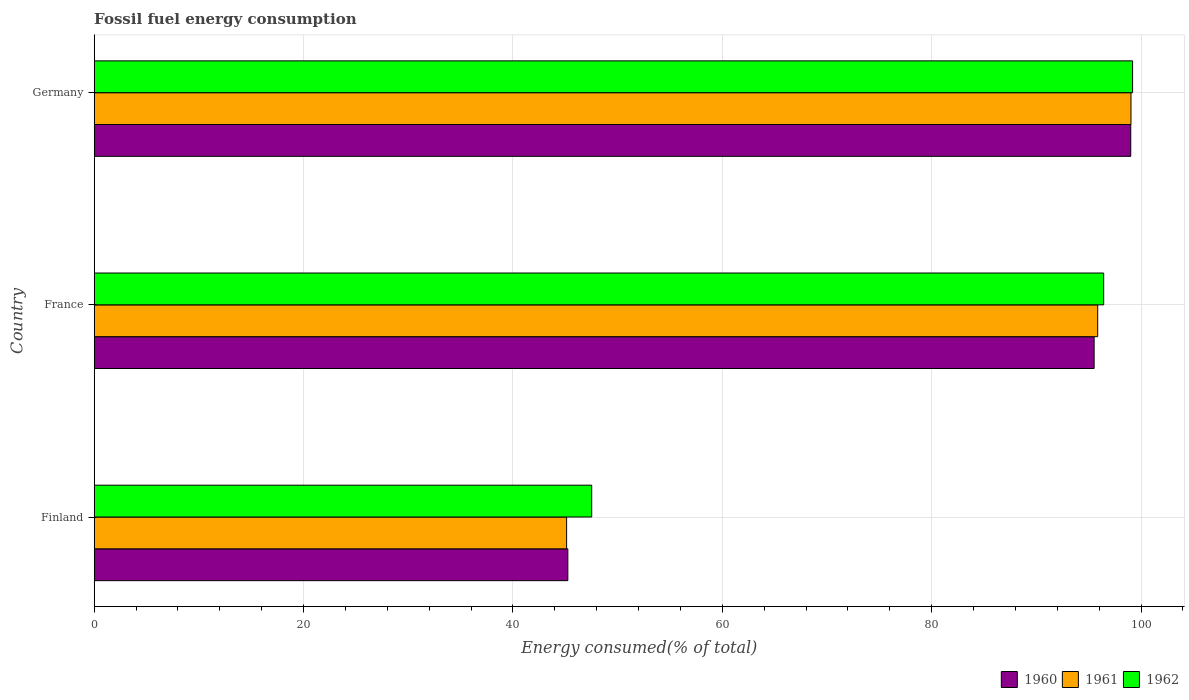How many groups of bars are there?
Ensure brevity in your answer.  3. Are the number of bars on each tick of the Y-axis equal?
Provide a succinct answer. Yes. In how many cases, is the number of bars for a given country not equal to the number of legend labels?
Ensure brevity in your answer.  0. What is the percentage of energy consumed in 1961 in Germany?
Keep it short and to the point. 99.04. Across all countries, what is the maximum percentage of energy consumed in 1960?
Give a very brief answer. 99.02. Across all countries, what is the minimum percentage of energy consumed in 1961?
Provide a short and direct response. 45.13. In which country was the percentage of energy consumed in 1962 maximum?
Your response must be concise. Germany. In which country was the percentage of energy consumed in 1962 minimum?
Offer a terse response. Finland. What is the total percentage of energy consumed in 1960 in the graph?
Give a very brief answer. 239.79. What is the difference between the percentage of energy consumed in 1961 in Finland and that in Germany?
Offer a terse response. -53.91. What is the difference between the percentage of energy consumed in 1960 in Germany and the percentage of energy consumed in 1961 in Finland?
Ensure brevity in your answer.  53.89. What is the average percentage of energy consumed in 1961 per country?
Give a very brief answer. 80.01. What is the difference between the percentage of energy consumed in 1960 and percentage of energy consumed in 1961 in France?
Your response must be concise. -0.34. What is the ratio of the percentage of energy consumed in 1960 in France to that in Germany?
Keep it short and to the point. 0.96. Is the percentage of energy consumed in 1960 in France less than that in Germany?
Make the answer very short. Yes. What is the difference between the highest and the second highest percentage of energy consumed in 1962?
Your answer should be compact. 2.76. What is the difference between the highest and the lowest percentage of energy consumed in 1960?
Offer a very short reply. 53.77. Is the sum of the percentage of energy consumed in 1960 in Finland and Germany greater than the maximum percentage of energy consumed in 1961 across all countries?
Your answer should be very brief. Yes. What does the 3rd bar from the top in Finland represents?
Ensure brevity in your answer.  1960. Are the values on the major ticks of X-axis written in scientific E-notation?
Your answer should be very brief. No. Does the graph contain any zero values?
Give a very brief answer. No. Does the graph contain grids?
Provide a succinct answer. Yes. How many legend labels are there?
Your answer should be very brief. 3. What is the title of the graph?
Your response must be concise. Fossil fuel energy consumption. What is the label or title of the X-axis?
Ensure brevity in your answer.  Energy consumed(% of total). What is the label or title of the Y-axis?
Offer a very short reply. Country. What is the Energy consumed(% of total) of 1960 in Finland?
Your answer should be compact. 45.25. What is the Energy consumed(% of total) in 1961 in Finland?
Your answer should be very brief. 45.13. What is the Energy consumed(% of total) in 1962 in Finland?
Provide a succinct answer. 47.52. What is the Energy consumed(% of total) of 1960 in France?
Provide a succinct answer. 95.52. What is the Energy consumed(% of total) in 1961 in France?
Make the answer very short. 95.86. What is the Energy consumed(% of total) of 1962 in France?
Your response must be concise. 96.43. What is the Energy consumed(% of total) of 1960 in Germany?
Offer a terse response. 99.02. What is the Energy consumed(% of total) of 1961 in Germany?
Ensure brevity in your answer.  99.04. What is the Energy consumed(% of total) of 1962 in Germany?
Offer a terse response. 99.19. Across all countries, what is the maximum Energy consumed(% of total) in 1960?
Your response must be concise. 99.02. Across all countries, what is the maximum Energy consumed(% of total) of 1961?
Give a very brief answer. 99.04. Across all countries, what is the maximum Energy consumed(% of total) of 1962?
Your answer should be compact. 99.19. Across all countries, what is the minimum Energy consumed(% of total) of 1960?
Provide a short and direct response. 45.25. Across all countries, what is the minimum Energy consumed(% of total) of 1961?
Ensure brevity in your answer.  45.13. Across all countries, what is the minimum Energy consumed(% of total) of 1962?
Offer a very short reply. 47.52. What is the total Energy consumed(% of total) in 1960 in the graph?
Your answer should be compact. 239.79. What is the total Energy consumed(% of total) in 1961 in the graph?
Make the answer very short. 240.03. What is the total Energy consumed(% of total) of 1962 in the graph?
Ensure brevity in your answer.  243.15. What is the difference between the Energy consumed(% of total) in 1960 in Finland and that in France?
Offer a terse response. -50.27. What is the difference between the Energy consumed(% of total) of 1961 in Finland and that in France?
Provide a short and direct response. -50.73. What is the difference between the Energy consumed(% of total) of 1962 in Finland and that in France?
Your response must be concise. -48.91. What is the difference between the Energy consumed(% of total) in 1960 in Finland and that in Germany?
Make the answer very short. -53.77. What is the difference between the Energy consumed(% of total) in 1961 in Finland and that in Germany?
Offer a very short reply. -53.91. What is the difference between the Energy consumed(% of total) in 1962 in Finland and that in Germany?
Provide a short and direct response. -51.67. What is the difference between the Energy consumed(% of total) of 1960 in France and that in Germany?
Make the answer very short. -3.5. What is the difference between the Energy consumed(% of total) in 1961 in France and that in Germany?
Offer a very short reply. -3.18. What is the difference between the Energy consumed(% of total) in 1962 in France and that in Germany?
Offer a very short reply. -2.76. What is the difference between the Energy consumed(% of total) in 1960 in Finland and the Energy consumed(% of total) in 1961 in France?
Give a very brief answer. -50.62. What is the difference between the Energy consumed(% of total) of 1960 in Finland and the Energy consumed(% of total) of 1962 in France?
Keep it short and to the point. -51.19. What is the difference between the Energy consumed(% of total) in 1961 in Finland and the Energy consumed(% of total) in 1962 in France?
Provide a succinct answer. -51.3. What is the difference between the Energy consumed(% of total) in 1960 in Finland and the Energy consumed(% of total) in 1961 in Germany?
Give a very brief answer. -53.8. What is the difference between the Energy consumed(% of total) of 1960 in Finland and the Energy consumed(% of total) of 1962 in Germany?
Ensure brevity in your answer.  -53.95. What is the difference between the Energy consumed(% of total) in 1961 in Finland and the Energy consumed(% of total) in 1962 in Germany?
Give a very brief answer. -54.06. What is the difference between the Energy consumed(% of total) in 1960 in France and the Energy consumed(% of total) in 1961 in Germany?
Provide a succinct answer. -3.52. What is the difference between the Energy consumed(% of total) of 1960 in France and the Energy consumed(% of total) of 1962 in Germany?
Ensure brevity in your answer.  -3.67. What is the difference between the Energy consumed(% of total) of 1961 in France and the Energy consumed(% of total) of 1962 in Germany?
Provide a short and direct response. -3.33. What is the average Energy consumed(% of total) of 1960 per country?
Keep it short and to the point. 79.93. What is the average Energy consumed(% of total) in 1961 per country?
Offer a terse response. 80.01. What is the average Energy consumed(% of total) of 1962 per country?
Your answer should be compact. 81.05. What is the difference between the Energy consumed(% of total) of 1960 and Energy consumed(% of total) of 1961 in Finland?
Ensure brevity in your answer.  0.12. What is the difference between the Energy consumed(% of total) of 1960 and Energy consumed(% of total) of 1962 in Finland?
Your answer should be very brief. -2.28. What is the difference between the Energy consumed(% of total) of 1961 and Energy consumed(% of total) of 1962 in Finland?
Make the answer very short. -2.4. What is the difference between the Energy consumed(% of total) of 1960 and Energy consumed(% of total) of 1961 in France?
Your answer should be compact. -0.34. What is the difference between the Energy consumed(% of total) in 1960 and Energy consumed(% of total) in 1962 in France?
Provide a succinct answer. -0.91. What is the difference between the Energy consumed(% of total) in 1961 and Energy consumed(% of total) in 1962 in France?
Provide a short and direct response. -0.57. What is the difference between the Energy consumed(% of total) in 1960 and Energy consumed(% of total) in 1961 in Germany?
Offer a terse response. -0.02. What is the difference between the Energy consumed(% of total) of 1960 and Energy consumed(% of total) of 1962 in Germany?
Provide a succinct answer. -0.17. What is the difference between the Energy consumed(% of total) in 1961 and Energy consumed(% of total) in 1962 in Germany?
Give a very brief answer. -0.15. What is the ratio of the Energy consumed(% of total) of 1960 in Finland to that in France?
Give a very brief answer. 0.47. What is the ratio of the Energy consumed(% of total) of 1961 in Finland to that in France?
Keep it short and to the point. 0.47. What is the ratio of the Energy consumed(% of total) of 1962 in Finland to that in France?
Provide a succinct answer. 0.49. What is the ratio of the Energy consumed(% of total) in 1960 in Finland to that in Germany?
Provide a succinct answer. 0.46. What is the ratio of the Energy consumed(% of total) in 1961 in Finland to that in Germany?
Offer a terse response. 0.46. What is the ratio of the Energy consumed(% of total) of 1962 in Finland to that in Germany?
Your answer should be very brief. 0.48. What is the ratio of the Energy consumed(% of total) in 1960 in France to that in Germany?
Keep it short and to the point. 0.96. What is the ratio of the Energy consumed(% of total) in 1961 in France to that in Germany?
Your answer should be very brief. 0.97. What is the ratio of the Energy consumed(% of total) in 1962 in France to that in Germany?
Your answer should be compact. 0.97. What is the difference between the highest and the second highest Energy consumed(% of total) of 1960?
Ensure brevity in your answer.  3.5. What is the difference between the highest and the second highest Energy consumed(% of total) of 1961?
Ensure brevity in your answer.  3.18. What is the difference between the highest and the second highest Energy consumed(% of total) of 1962?
Your answer should be very brief. 2.76. What is the difference between the highest and the lowest Energy consumed(% of total) in 1960?
Offer a terse response. 53.77. What is the difference between the highest and the lowest Energy consumed(% of total) of 1961?
Your answer should be very brief. 53.91. What is the difference between the highest and the lowest Energy consumed(% of total) in 1962?
Your response must be concise. 51.67. 